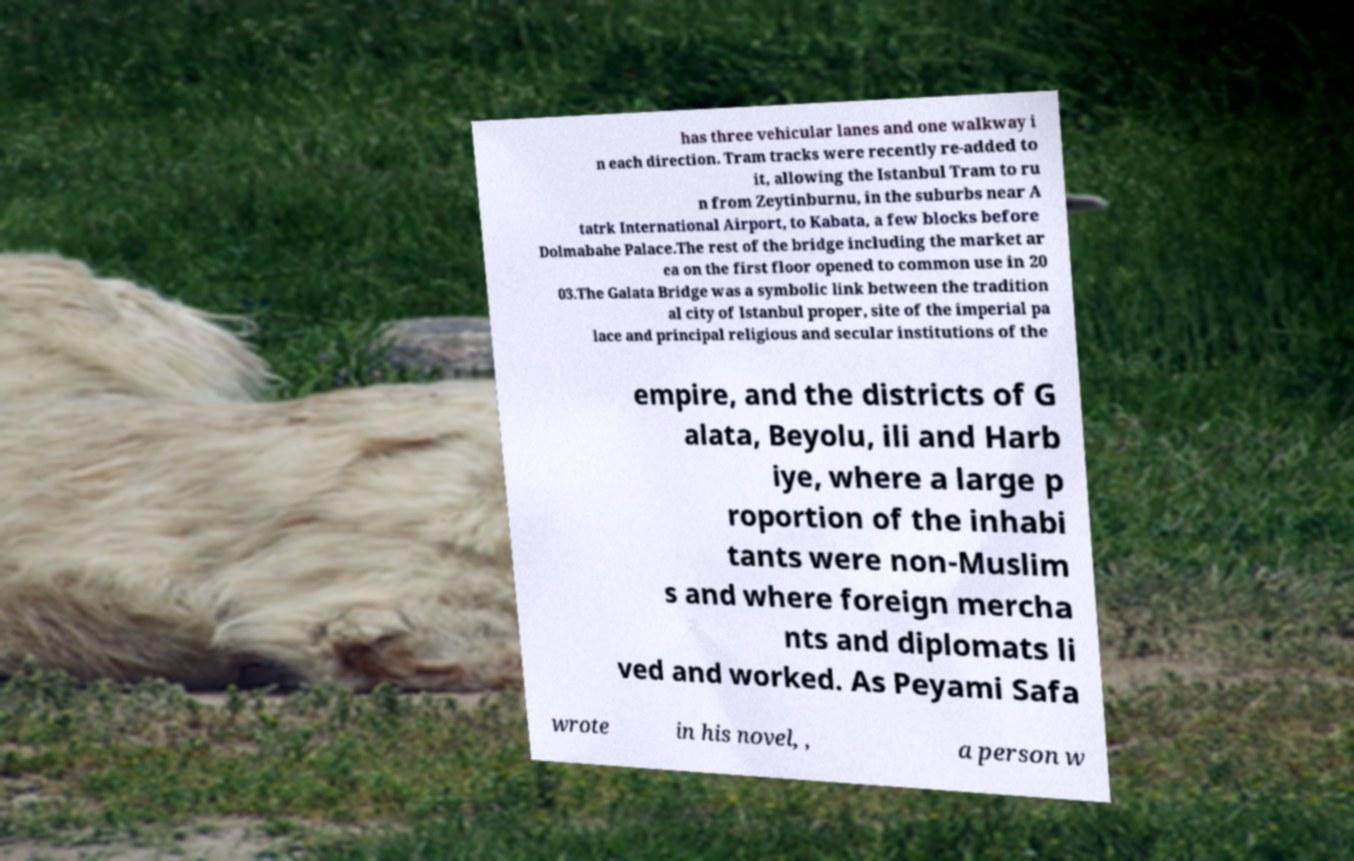What messages or text are displayed in this image? I need them in a readable, typed format. has three vehicular lanes and one walkway i n each direction. Tram tracks were recently re-added to it, allowing the Istanbul Tram to ru n from Zeytinburnu, in the suburbs near A tatrk International Airport, to Kabata, a few blocks before Dolmabahe Palace.The rest of the bridge including the market ar ea on the first floor opened to common use in 20 03.The Galata Bridge was a symbolic link between the tradition al city of Istanbul proper, site of the imperial pa lace and principal religious and secular institutions of the empire, and the districts of G alata, Beyolu, ili and Harb iye, where a large p roportion of the inhabi tants were non-Muslim s and where foreign mercha nts and diplomats li ved and worked. As Peyami Safa wrote in his novel, , a person w 